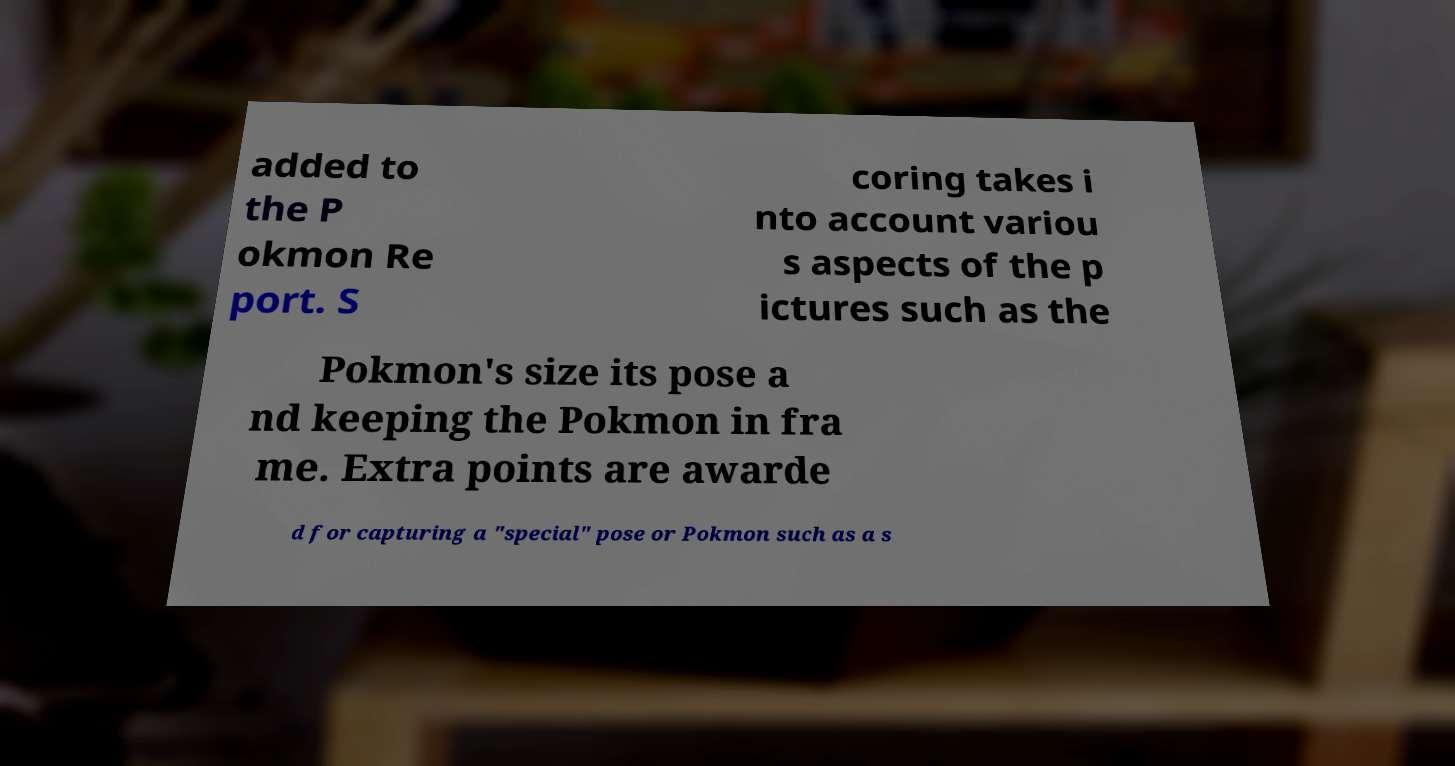Please identify and transcribe the text found in this image. added to the P okmon Re port. S coring takes i nto account variou s aspects of the p ictures such as the Pokmon's size its pose a nd keeping the Pokmon in fra me. Extra points are awarde d for capturing a "special" pose or Pokmon such as a s 